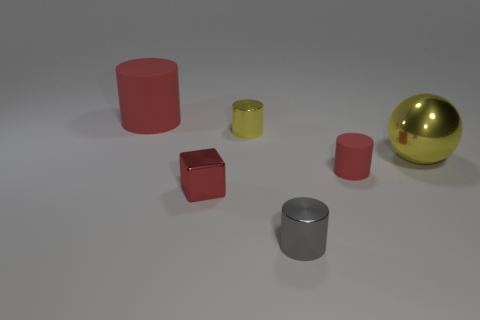Add 2 big red matte objects. How many objects exist? 8 Subtract all spheres. How many objects are left? 5 Add 3 big red matte things. How many big red matte things are left? 4 Add 3 big red matte blocks. How many big red matte blocks exist? 3 Subtract 1 red cubes. How many objects are left? 5 Subtract all purple metal cubes. Subtract all big matte objects. How many objects are left? 5 